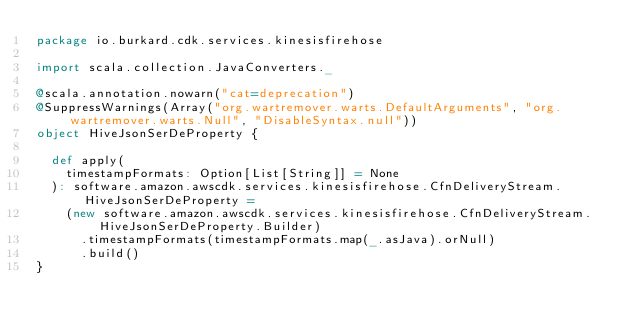Convert code to text. <code><loc_0><loc_0><loc_500><loc_500><_Scala_>package io.burkard.cdk.services.kinesisfirehose

import scala.collection.JavaConverters._

@scala.annotation.nowarn("cat=deprecation")
@SuppressWarnings(Array("org.wartremover.warts.DefaultArguments", "org.wartremover.warts.Null", "DisableSyntax.null"))
object HiveJsonSerDeProperty {

  def apply(
    timestampFormats: Option[List[String]] = None
  ): software.amazon.awscdk.services.kinesisfirehose.CfnDeliveryStream.HiveJsonSerDeProperty =
    (new software.amazon.awscdk.services.kinesisfirehose.CfnDeliveryStream.HiveJsonSerDeProperty.Builder)
      .timestampFormats(timestampFormats.map(_.asJava).orNull)
      .build()
}
</code> 